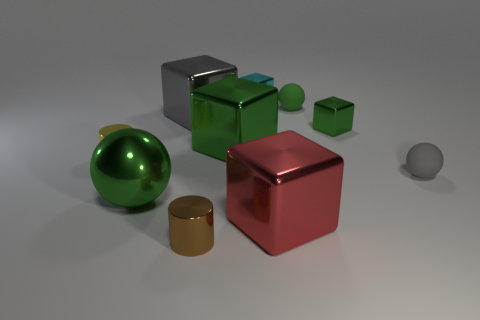What is the color of the other rubber object that is the same shape as the tiny gray object?
Your answer should be compact. Green. What is the size of the gray matte object that is the same shape as the green matte object?
Offer a very short reply. Small. There is a ball that is the same material as the tiny brown object; what color is it?
Provide a succinct answer. Green. What color is the big cube left of the small metallic cylinder right of the tiny cylinder behind the gray matte thing?
Your response must be concise. Gray. There is a yellow metallic object; does it have the same size as the gray object that is right of the tiny brown object?
Provide a succinct answer. Yes. How many things are big blocks behind the large ball or tiny shiny things that are in front of the tiny gray rubber object?
Offer a very short reply. 3. What shape is the green shiny thing that is the same size as the shiny sphere?
Give a very brief answer. Cube. What shape is the metal object that is behind the gray thing that is left of the tiny shiny cylinder on the right side of the large sphere?
Offer a very short reply. Cube. Are there an equal number of small brown things that are on the right side of the brown cylinder and small cyan matte cylinders?
Ensure brevity in your answer.  Yes. Do the gray matte object and the cyan block have the same size?
Provide a succinct answer. Yes. 